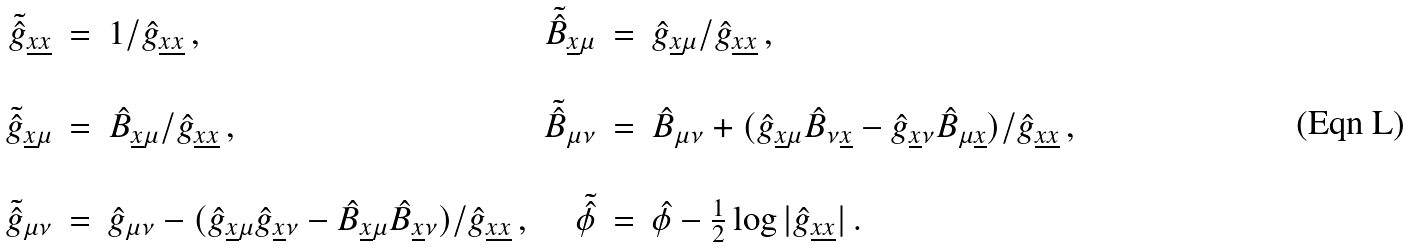Convert formula to latex. <formula><loc_0><loc_0><loc_500><loc_500>\begin{array} { r c l r c l } \tilde { \hat { g } } _ { \underline { x } \underline { x } } & = & 1 / \hat { g } _ { \underline { x } \underline { x } } \, , & \tilde { \hat { B } } _ { \underline { x } \mu } & = & \hat { g } _ { \underline { x } \mu } / \hat { g } _ { \underline { x } \underline { x } } \, , \\ & & & & & \\ \tilde { \hat { g } } _ { \underline { x } \mu } & = & \hat { B } _ { \underline { x } \mu } / \hat { g } _ { \underline { x } \underline { x } } \, , & \tilde { \hat { B } } _ { \mu \nu } & = & \hat { B } _ { \mu \nu } + ( \hat { g } _ { \underline { x } \mu } \hat { B } _ { \nu \underline { x } } - \hat { g } _ { \underline { x } \nu } \hat { B } _ { \mu \underline { x } } ) / \hat { g } _ { \underline { x } \underline { x } } \, , \\ & & & & & \\ \tilde { \hat { g } } _ { \mu \nu } & = & \hat { g } _ { \mu \nu } - ( \hat { g } _ { \underline { x } \mu } \hat { g } _ { \underline { x } \nu } - \hat { B } _ { \underline { x } \mu } \hat { B } _ { \underline { x } \nu } ) / \hat { g } _ { \underline { x } \underline { x } } \, , & \tilde { \hat { \phi } } & = & \hat { \phi } - \frac { 1 } { 2 } \log | \hat { g } _ { \underline { x } \underline { x } } | \, . \end{array}</formula> 